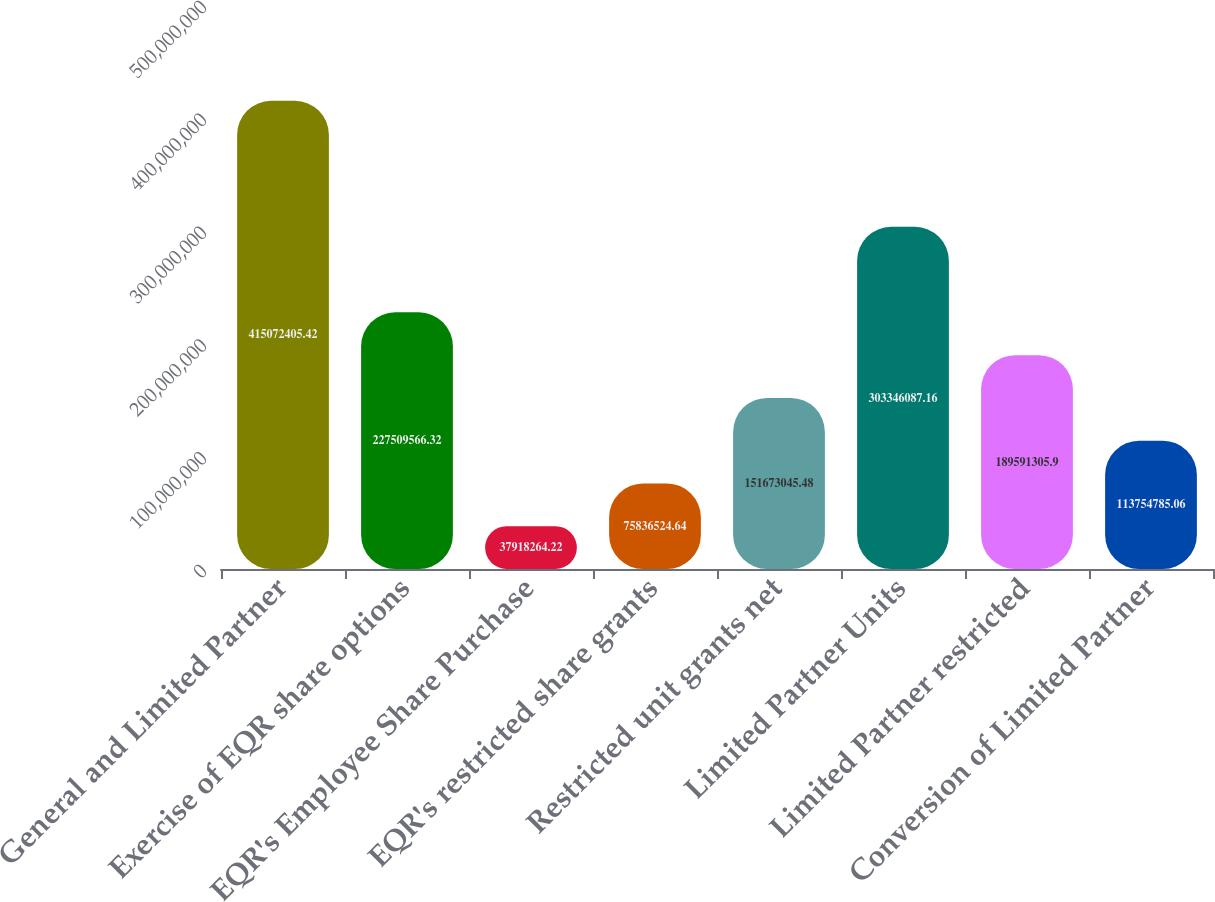Convert chart to OTSL. <chart><loc_0><loc_0><loc_500><loc_500><bar_chart><fcel>General and Limited Partner<fcel>Exercise of EQR share options<fcel>EQR's Employee Share Purchase<fcel>EQR's restricted share grants<fcel>Restricted unit grants net<fcel>Limited Partner Units<fcel>Limited Partner restricted<fcel>Conversion of Limited Partner<nl><fcel>4.15072e+08<fcel>2.2751e+08<fcel>3.79183e+07<fcel>7.58365e+07<fcel>1.51673e+08<fcel>3.03346e+08<fcel>1.89591e+08<fcel>1.13755e+08<nl></chart> 